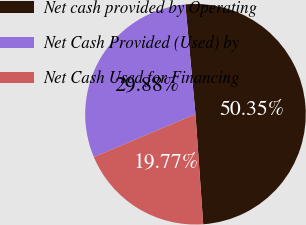Convert chart to OTSL. <chart><loc_0><loc_0><loc_500><loc_500><pie_chart><fcel>Net cash provided by Operating<fcel>Net Cash Provided (Used) by<fcel>Net Cash Used for Financing<nl><fcel>50.35%<fcel>29.88%<fcel>19.77%<nl></chart> 